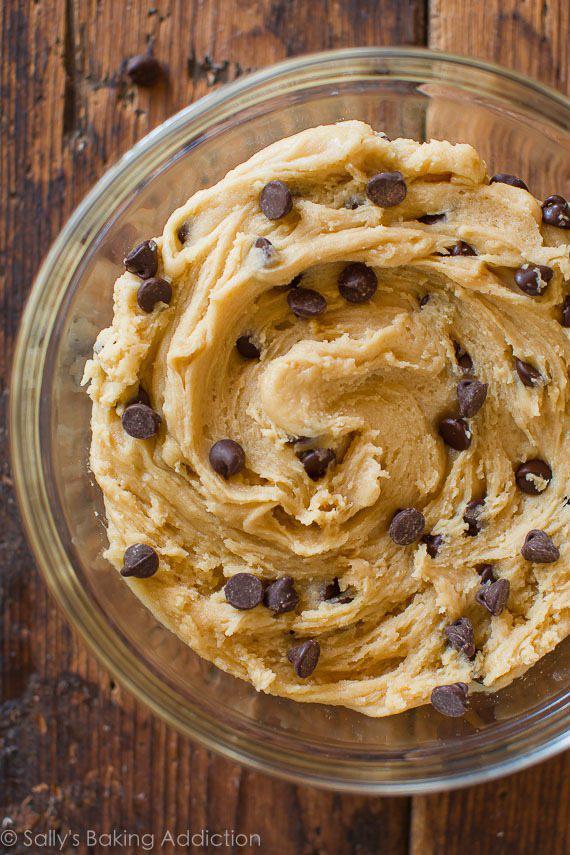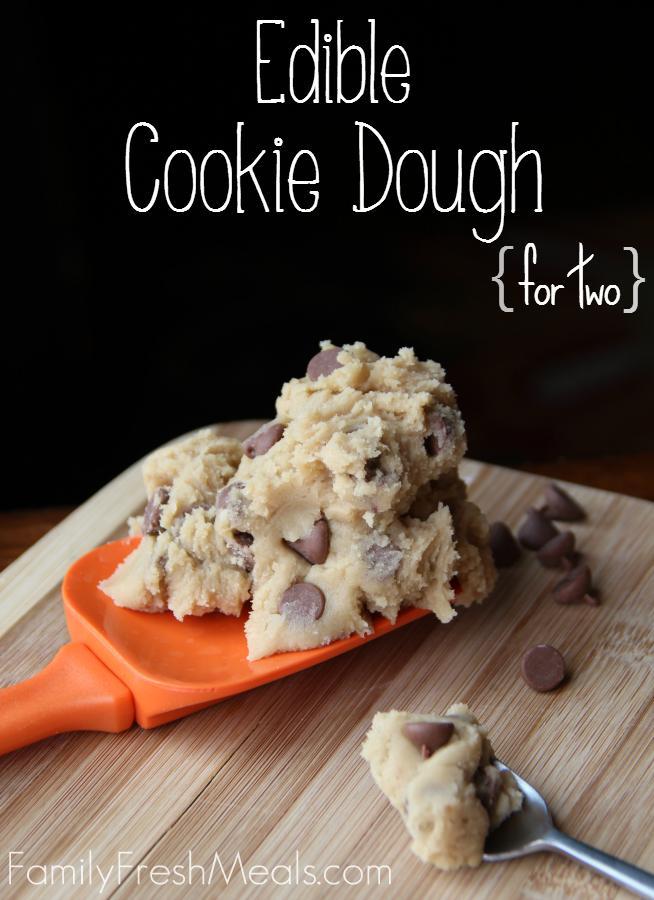The first image is the image on the left, the second image is the image on the right. For the images displayed, is the sentence "A spoon is laying on the table." factually correct? Answer yes or no. Yes. The first image is the image on the left, the second image is the image on the right. Given the left and right images, does the statement "There is a single glass bowl holding chocolate chip cookie dough." hold true? Answer yes or no. Yes. 